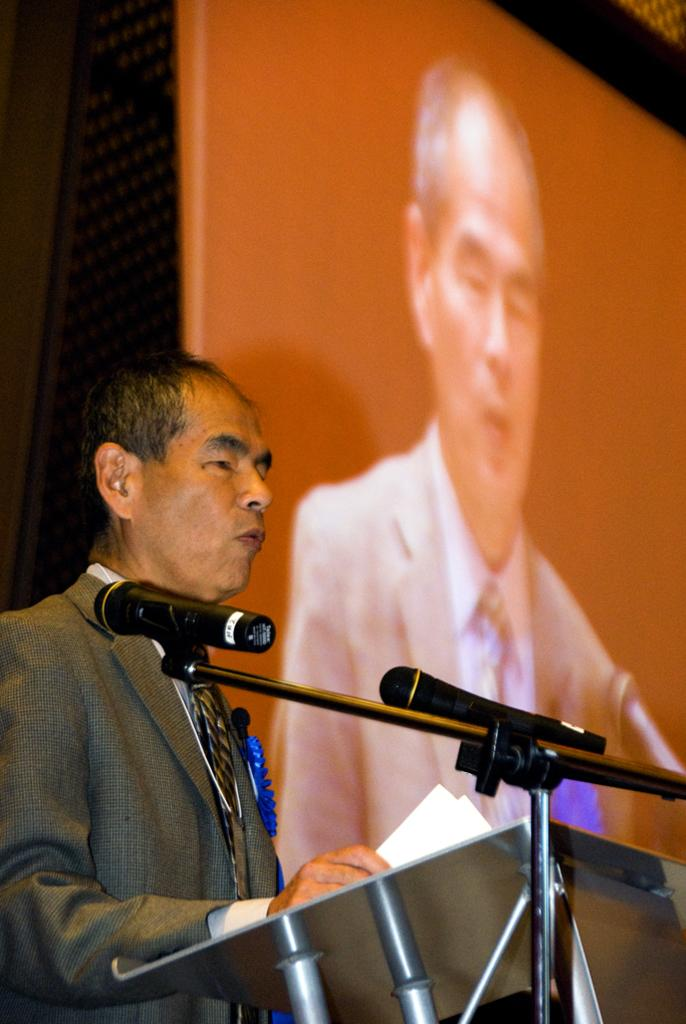What is the person in the image doing? The person is holding papers and standing near a podium. What can be seen beside the podium? There is a stand with mics beside the podium. What is in the background of the image? There is a screen in the background. How many sisters are standing next to the person in the image? There is no mention of any sisters in the image, so we cannot determine their presence or number. 